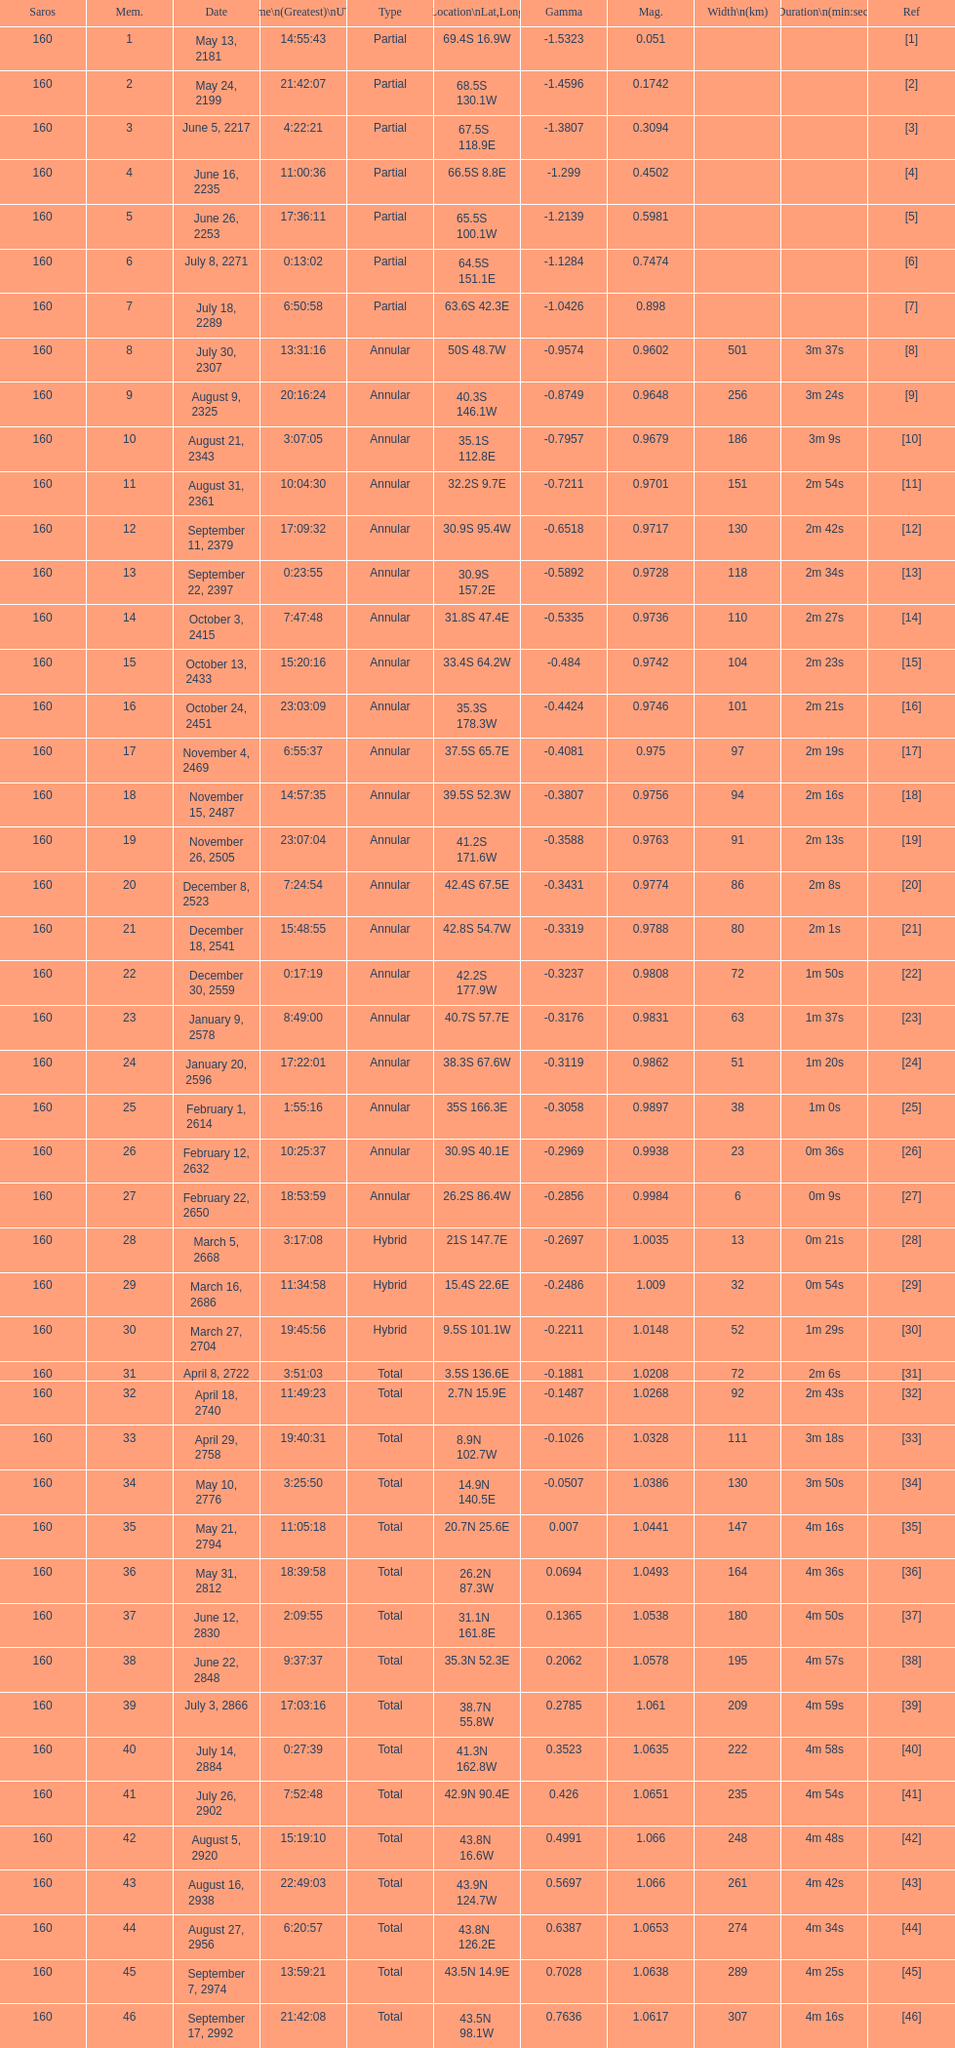What is the difference in magnitude between the may 13, 2181 solar saros and the may 24, 2199 solar saros? 0.1232. 